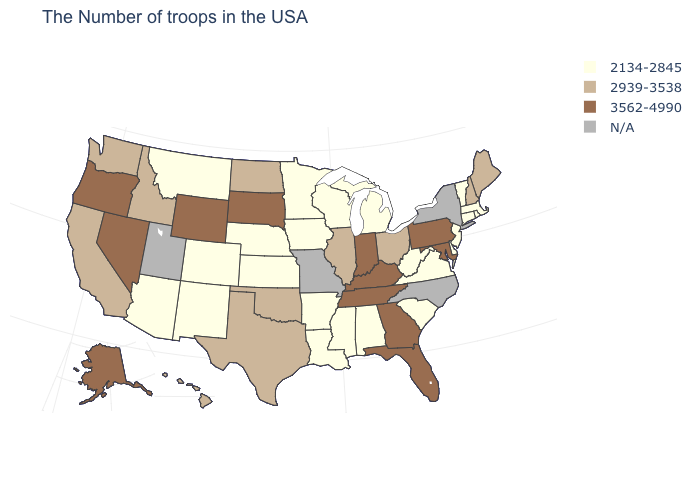Name the states that have a value in the range 2939-3538?
Answer briefly. Maine, New Hampshire, Ohio, Illinois, Oklahoma, Texas, North Dakota, Idaho, California, Washington, Hawaii. How many symbols are there in the legend?
Short answer required. 4. How many symbols are there in the legend?
Concise answer only. 4. What is the value of Indiana?
Give a very brief answer. 3562-4990. What is the value of Arizona?
Answer briefly. 2134-2845. Name the states that have a value in the range N/A?
Concise answer only. New York, North Carolina, Missouri, Utah. Name the states that have a value in the range N/A?
Answer briefly. New York, North Carolina, Missouri, Utah. What is the lowest value in states that border Kentucky?
Short answer required. 2134-2845. Is the legend a continuous bar?
Concise answer only. No. What is the value of Maryland?
Give a very brief answer. 3562-4990. Which states have the lowest value in the USA?
Give a very brief answer. Massachusetts, Rhode Island, Vermont, Connecticut, New Jersey, Delaware, Virginia, South Carolina, West Virginia, Michigan, Alabama, Wisconsin, Mississippi, Louisiana, Arkansas, Minnesota, Iowa, Kansas, Nebraska, Colorado, New Mexico, Montana, Arizona. Among the states that border Wisconsin , which have the highest value?
Write a very short answer. Illinois. What is the lowest value in the USA?
Keep it brief. 2134-2845. What is the value of Mississippi?
Concise answer only. 2134-2845. How many symbols are there in the legend?
Give a very brief answer. 4. 